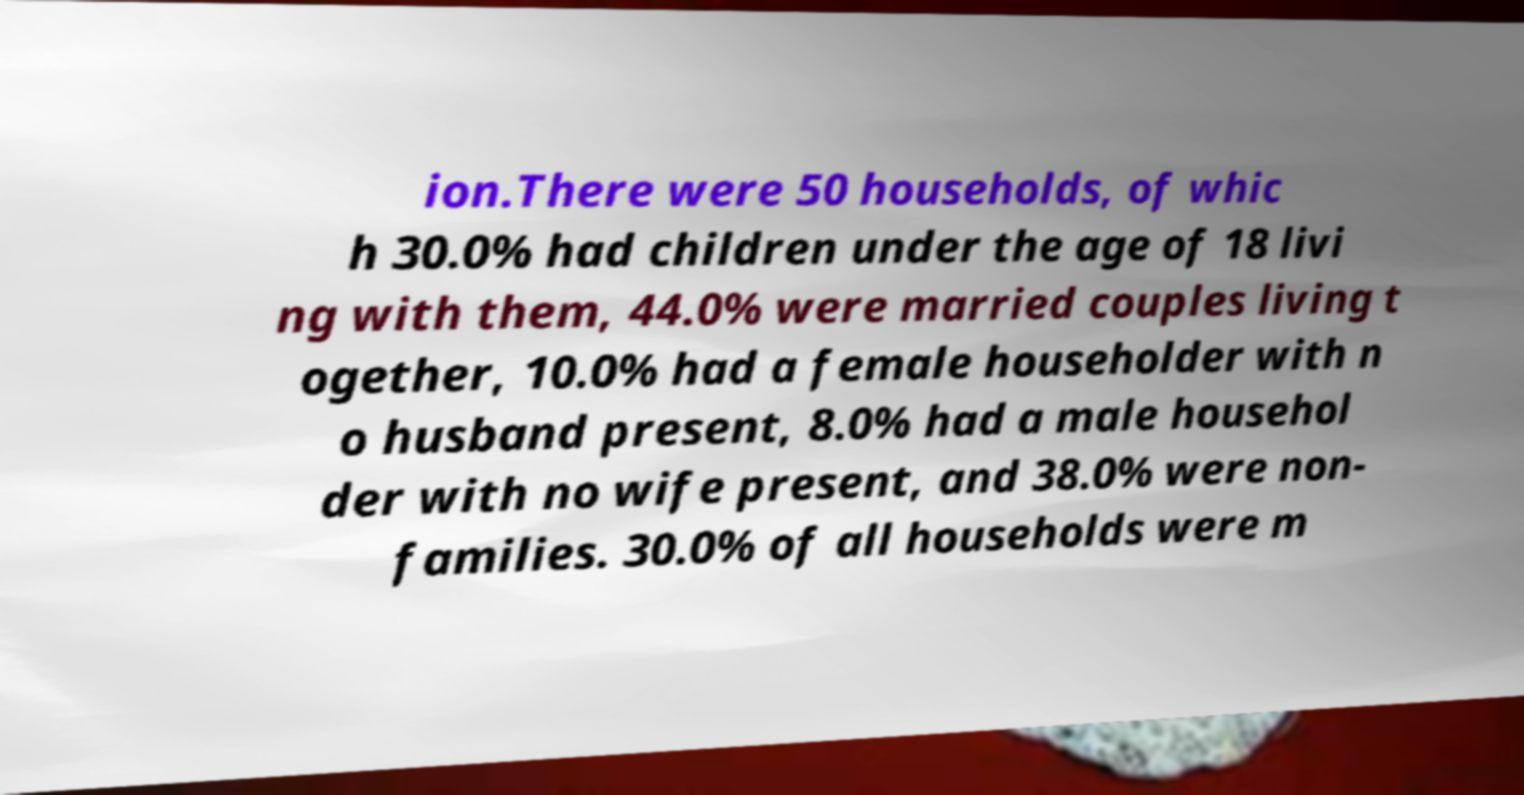Could you assist in decoding the text presented in this image and type it out clearly? ion.There were 50 households, of whic h 30.0% had children under the age of 18 livi ng with them, 44.0% were married couples living t ogether, 10.0% had a female householder with n o husband present, 8.0% had a male househol der with no wife present, and 38.0% were non- families. 30.0% of all households were m 